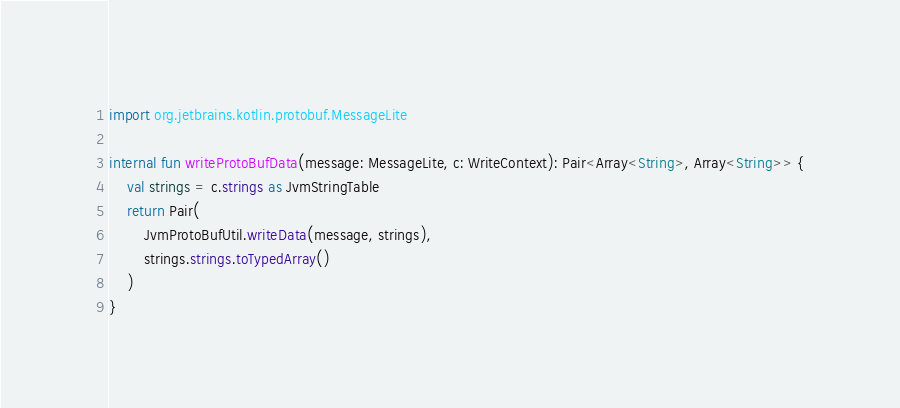Convert code to text. <code><loc_0><loc_0><loc_500><loc_500><_Kotlin_>import org.jetbrains.kotlin.protobuf.MessageLite

internal fun writeProtoBufData(message: MessageLite, c: WriteContext): Pair<Array<String>, Array<String>> {
    val strings = c.strings as JvmStringTable
    return Pair(
        JvmProtoBufUtil.writeData(message, strings),
        strings.strings.toTypedArray()
    )
}
</code> 